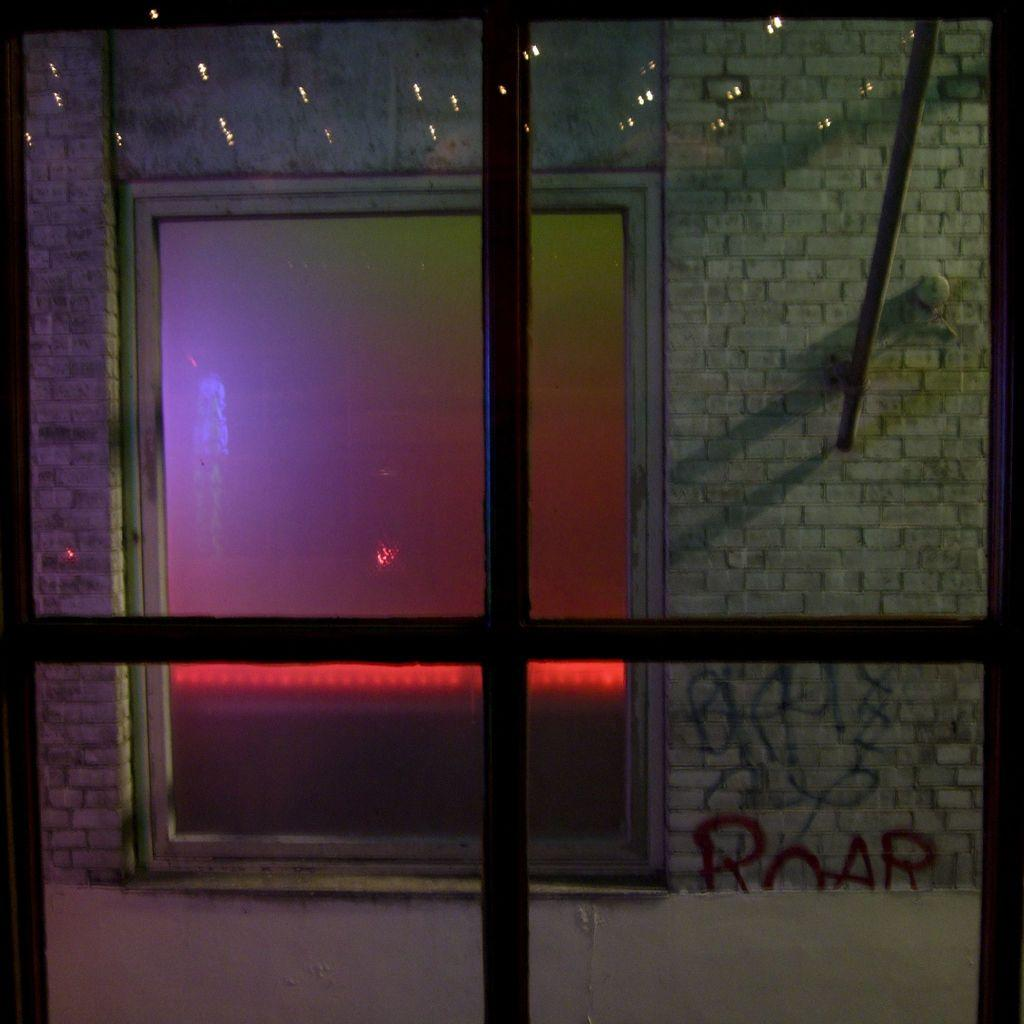What type of material is used for the windows in the image? There are glass windows in the image. What can be seen through the glass windows? A brick wall is visible through the glass windows. Are there any other glass windows in the image? Yes, there is another set of glass windows in the image. What type of poison is being spread through the alley in the image? There is no alley or poison present in the image; it only features glass windows and a brick wall. 